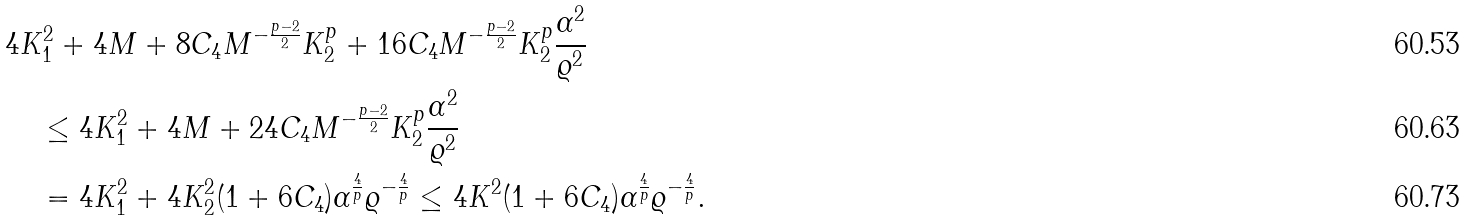<formula> <loc_0><loc_0><loc_500><loc_500>& 4 K _ { 1 } ^ { 2 } + 4 M + 8 C _ { 4 } M ^ { - \frac { p - 2 } { 2 } } K _ { 2 } ^ { p } + 1 6 C _ { 4 } M ^ { - \frac { p - 2 } { 2 } } K _ { 2 } ^ { p } \frac { \alpha ^ { 2 } } { \varrho ^ { 2 } } \\ & \quad \leq 4 K _ { 1 } ^ { 2 } + 4 M + 2 4 C _ { 4 } M ^ { - \frac { p - 2 } { 2 } } K _ { 2 } ^ { p } \frac { \alpha ^ { 2 } } { \varrho ^ { 2 } } \\ & \quad = 4 K _ { 1 } ^ { 2 } + 4 K _ { 2 } ^ { 2 } ( 1 + 6 C _ { 4 } ) \alpha ^ { \frac { 4 } { p } } \varrho ^ { - \frac { 4 } { p } } \leq 4 K ^ { 2 } ( 1 + 6 C _ { 4 } ) \alpha ^ { \frac { 4 } { p } } \varrho ^ { - \frac { 4 } { p } } .</formula> 